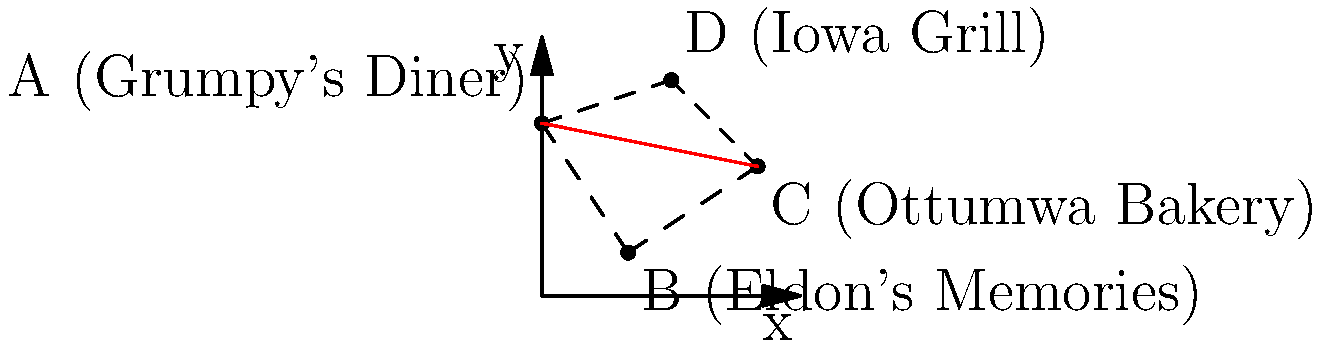You've just moved from Eldon to Ottumwa and need to visit some local businesses. Using the city map with coordinate overlay, determine the shortest route between Grumpy's Diner (A) and Ottumwa Bakery (C). What is the distance between these two points? To find the shortest distance between two points on a coordinate plane, we can use the distance formula:

$$ d = \sqrt{(x_2 - x_1)^2 + (y_2 - y_1)^2} $$

Where $(x_1, y_1)$ are the coordinates of the first point and $(x_2, y_2)$ are the coordinates of the second point.

Step 1: Identify the coordinates
- Grumpy's Diner (A): $(0, 4)$
- Ottumwa Bakery (C): $(5, 3)$

Step 2: Plug the coordinates into the distance formula
$$ d = \sqrt{(5 - 0)^2 + (3 - 4)^2} $$

Step 3: Simplify the expressions inside the parentheses
$$ d = \sqrt{5^2 + (-1)^2} $$

Step 4: Calculate the squares
$$ d = \sqrt{25 + 1} $$

Step 5: Add the numbers under the square root
$$ d = \sqrt{26} $$

The shortest distance between Grumpy's Diner and Ottumwa Bakery is $\sqrt{26}$ units on the coordinate map.
Answer: $\sqrt{26}$ units 